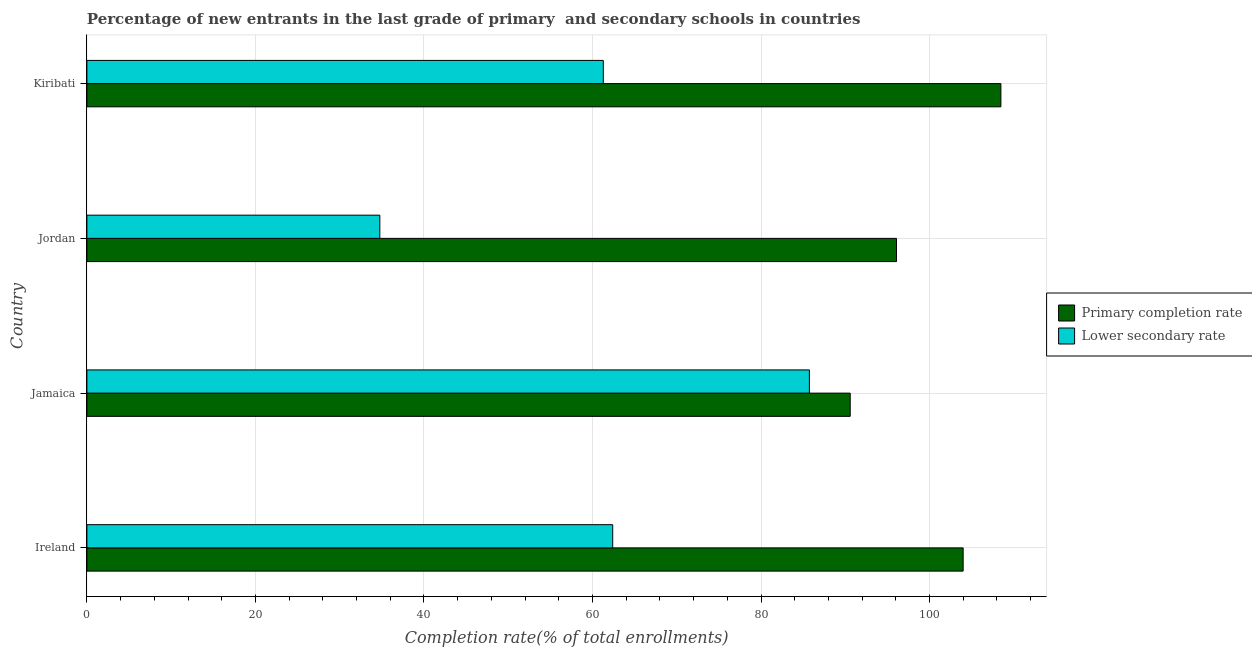How many different coloured bars are there?
Provide a short and direct response. 2. Are the number of bars per tick equal to the number of legend labels?
Make the answer very short. Yes. How many bars are there on the 3rd tick from the top?
Offer a terse response. 2. What is the label of the 2nd group of bars from the top?
Offer a very short reply. Jordan. In how many cases, is the number of bars for a given country not equal to the number of legend labels?
Provide a succinct answer. 0. What is the completion rate in secondary schools in Jordan?
Provide a succinct answer. 34.76. Across all countries, what is the maximum completion rate in primary schools?
Your answer should be compact. 108.47. Across all countries, what is the minimum completion rate in primary schools?
Keep it short and to the point. 90.59. In which country was the completion rate in secondary schools maximum?
Keep it short and to the point. Jamaica. In which country was the completion rate in secondary schools minimum?
Provide a short and direct response. Jordan. What is the total completion rate in secondary schools in the graph?
Your response must be concise. 244.2. What is the difference between the completion rate in primary schools in Jamaica and that in Kiribati?
Ensure brevity in your answer.  -17.88. What is the difference between the completion rate in primary schools in Ireland and the completion rate in secondary schools in Jordan?
Keep it short and to the point. 69.23. What is the average completion rate in secondary schools per country?
Ensure brevity in your answer.  61.05. What is the difference between the completion rate in secondary schools and completion rate in primary schools in Jamaica?
Your response must be concise. -4.84. In how many countries, is the completion rate in primary schools greater than 96 %?
Provide a succinct answer. 3. What is the ratio of the completion rate in secondary schools in Jordan to that in Kiribati?
Offer a very short reply. 0.57. Is the difference between the completion rate in secondary schools in Ireland and Jordan greater than the difference between the completion rate in primary schools in Ireland and Jordan?
Provide a short and direct response. Yes. What is the difference between the highest and the second highest completion rate in primary schools?
Your answer should be compact. 4.48. What is the difference between the highest and the lowest completion rate in primary schools?
Give a very brief answer. 17.88. Is the sum of the completion rate in primary schools in Ireland and Kiribati greater than the maximum completion rate in secondary schools across all countries?
Offer a very short reply. Yes. What does the 1st bar from the top in Ireland represents?
Make the answer very short. Lower secondary rate. What does the 2nd bar from the bottom in Jordan represents?
Ensure brevity in your answer.  Lower secondary rate. How many bars are there?
Make the answer very short. 8. Are all the bars in the graph horizontal?
Provide a short and direct response. Yes. How many countries are there in the graph?
Provide a short and direct response. 4. What is the difference between two consecutive major ticks on the X-axis?
Your response must be concise. 20. Does the graph contain grids?
Keep it short and to the point. Yes. Where does the legend appear in the graph?
Your answer should be compact. Center right. How many legend labels are there?
Make the answer very short. 2. What is the title of the graph?
Your answer should be compact. Percentage of new entrants in the last grade of primary  and secondary schools in countries. Does "Agricultural land" appear as one of the legend labels in the graph?
Your answer should be compact. No. What is the label or title of the X-axis?
Offer a terse response. Completion rate(% of total enrollments). What is the Completion rate(% of total enrollments) in Primary completion rate in Ireland?
Your answer should be compact. 103.99. What is the Completion rate(% of total enrollments) of Lower secondary rate in Ireland?
Offer a terse response. 62.4. What is the Completion rate(% of total enrollments) of Primary completion rate in Jamaica?
Ensure brevity in your answer.  90.59. What is the Completion rate(% of total enrollments) of Lower secondary rate in Jamaica?
Provide a short and direct response. 85.74. What is the Completion rate(% of total enrollments) in Primary completion rate in Jordan?
Offer a very short reply. 96.08. What is the Completion rate(% of total enrollments) in Lower secondary rate in Jordan?
Keep it short and to the point. 34.76. What is the Completion rate(% of total enrollments) in Primary completion rate in Kiribati?
Make the answer very short. 108.47. What is the Completion rate(% of total enrollments) in Lower secondary rate in Kiribati?
Your answer should be very brief. 61.29. Across all countries, what is the maximum Completion rate(% of total enrollments) in Primary completion rate?
Keep it short and to the point. 108.47. Across all countries, what is the maximum Completion rate(% of total enrollments) of Lower secondary rate?
Your response must be concise. 85.74. Across all countries, what is the minimum Completion rate(% of total enrollments) of Primary completion rate?
Your answer should be very brief. 90.59. Across all countries, what is the minimum Completion rate(% of total enrollments) in Lower secondary rate?
Offer a very short reply. 34.76. What is the total Completion rate(% of total enrollments) of Primary completion rate in the graph?
Make the answer very short. 399.13. What is the total Completion rate(% of total enrollments) in Lower secondary rate in the graph?
Ensure brevity in your answer.  244.2. What is the difference between the Completion rate(% of total enrollments) of Primary completion rate in Ireland and that in Jamaica?
Your answer should be compact. 13.4. What is the difference between the Completion rate(% of total enrollments) of Lower secondary rate in Ireland and that in Jamaica?
Give a very brief answer. -23.34. What is the difference between the Completion rate(% of total enrollments) of Primary completion rate in Ireland and that in Jordan?
Make the answer very short. 7.91. What is the difference between the Completion rate(% of total enrollments) of Lower secondary rate in Ireland and that in Jordan?
Offer a very short reply. 27.64. What is the difference between the Completion rate(% of total enrollments) of Primary completion rate in Ireland and that in Kiribati?
Ensure brevity in your answer.  -4.48. What is the difference between the Completion rate(% of total enrollments) in Lower secondary rate in Ireland and that in Kiribati?
Offer a very short reply. 1.12. What is the difference between the Completion rate(% of total enrollments) in Primary completion rate in Jamaica and that in Jordan?
Offer a very short reply. -5.49. What is the difference between the Completion rate(% of total enrollments) of Lower secondary rate in Jamaica and that in Jordan?
Provide a succinct answer. 50.98. What is the difference between the Completion rate(% of total enrollments) of Primary completion rate in Jamaica and that in Kiribati?
Give a very brief answer. -17.88. What is the difference between the Completion rate(% of total enrollments) in Lower secondary rate in Jamaica and that in Kiribati?
Your response must be concise. 24.46. What is the difference between the Completion rate(% of total enrollments) in Primary completion rate in Jordan and that in Kiribati?
Provide a short and direct response. -12.39. What is the difference between the Completion rate(% of total enrollments) in Lower secondary rate in Jordan and that in Kiribati?
Give a very brief answer. -26.52. What is the difference between the Completion rate(% of total enrollments) of Primary completion rate in Ireland and the Completion rate(% of total enrollments) of Lower secondary rate in Jamaica?
Offer a terse response. 18.25. What is the difference between the Completion rate(% of total enrollments) in Primary completion rate in Ireland and the Completion rate(% of total enrollments) in Lower secondary rate in Jordan?
Your answer should be very brief. 69.23. What is the difference between the Completion rate(% of total enrollments) of Primary completion rate in Ireland and the Completion rate(% of total enrollments) of Lower secondary rate in Kiribati?
Your answer should be very brief. 42.7. What is the difference between the Completion rate(% of total enrollments) of Primary completion rate in Jamaica and the Completion rate(% of total enrollments) of Lower secondary rate in Jordan?
Give a very brief answer. 55.82. What is the difference between the Completion rate(% of total enrollments) in Primary completion rate in Jamaica and the Completion rate(% of total enrollments) in Lower secondary rate in Kiribati?
Provide a succinct answer. 29.3. What is the difference between the Completion rate(% of total enrollments) of Primary completion rate in Jordan and the Completion rate(% of total enrollments) of Lower secondary rate in Kiribati?
Provide a succinct answer. 34.79. What is the average Completion rate(% of total enrollments) of Primary completion rate per country?
Your response must be concise. 99.78. What is the average Completion rate(% of total enrollments) in Lower secondary rate per country?
Offer a very short reply. 61.05. What is the difference between the Completion rate(% of total enrollments) of Primary completion rate and Completion rate(% of total enrollments) of Lower secondary rate in Ireland?
Offer a very short reply. 41.59. What is the difference between the Completion rate(% of total enrollments) in Primary completion rate and Completion rate(% of total enrollments) in Lower secondary rate in Jamaica?
Keep it short and to the point. 4.84. What is the difference between the Completion rate(% of total enrollments) of Primary completion rate and Completion rate(% of total enrollments) of Lower secondary rate in Jordan?
Provide a succinct answer. 61.32. What is the difference between the Completion rate(% of total enrollments) in Primary completion rate and Completion rate(% of total enrollments) in Lower secondary rate in Kiribati?
Offer a terse response. 47.18. What is the ratio of the Completion rate(% of total enrollments) in Primary completion rate in Ireland to that in Jamaica?
Your response must be concise. 1.15. What is the ratio of the Completion rate(% of total enrollments) of Lower secondary rate in Ireland to that in Jamaica?
Provide a succinct answer. 0.73. What is the ratio of the Completion rate(% of total enrollments) in Primary completion rate in Ireland to that in Jordan?
Ensure brevity in your answer.  1.08. What is the ratio of the Completion rate(% of total enrollments) of Lower secondary rate in Ireland to that in Jordan?
Give a very brief answer. 1.8. What is the ratio of the Completion rate(% of total enrollments) in Primary completion rate in Ireland to that in Kiribati?
Make the answer very short. 0.96. What is the ratio of the Completion rate(% of total enrollments) in Lower secondary rate in Ireland to that in Kiribati?
Make the answer very short. 1.02. What is the ratio of the Completion rate(% of total enrollments) of Primary completion rate in Jamaica to that in Jordan?
Make the answer very short. 0.94. What is the ratio of the Completion rate(% of total enrollments) in Lower secondary rate in Jamaica to that in Jordan?
Make the answer very short. 2.47. What is the ratio of the Completion rate(% of total enrollments) in Primary completion rate in Jamaica to that in Kiribati?
Ensure brevity in your answer.  0.84. What is the ratio of the Completion rate(% of total enrollments) in Lower secondary rate in Jamaica to that in Kiribati?
Your answer should be compact. 1.4. What is the ratio of the Completion rate(% of total enrollments) of Primary completion rate in Jordan to that in Kiribati?
Offer a terse response. 0.89. What is the ratio of the Completion rate(% of total enrollments) of Lower secondary rate in Jordan to that in Kiribati?
Offer a terse response. 0.57. What is the difference between the highest and the second highest Completion rate(% of total enrollments) in Primary completion rate?
Offer a terse response. 4.48. What is the difference between the highest and the second highest Completion rate(% of total enrollments) of Lower secondary rate?
Offer a terse response. 23.34. What is the difference between the highest and the lowest Completion rate(% of total enrollments) of Primary completion rate?
Provide a short and direct response. 17.88. What is the difference between the highest and the lowest Completion rate(% of total enrollments) in Lower secondary rate?
Ensure brevity in your answer.  50.98. 